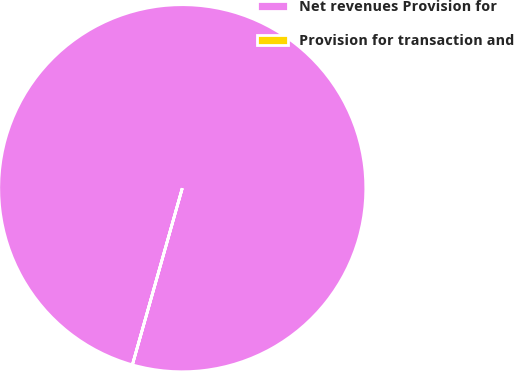<chart> <loc_0><loc_0><loc_500><loc_500><pie_chart><fcel>Net revenues Provision for<fcel>Provision for transaction and<nl><fcel>100.0%<fcel>0.0%<nl></chart> 